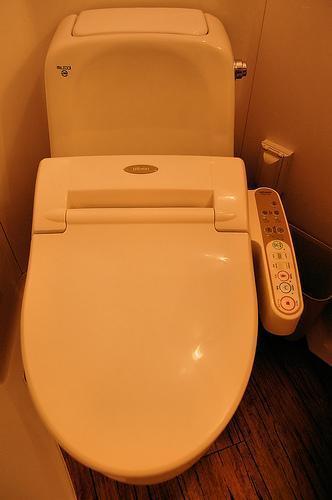How many button lights are shining green?
Give a very brief answer. 3. 